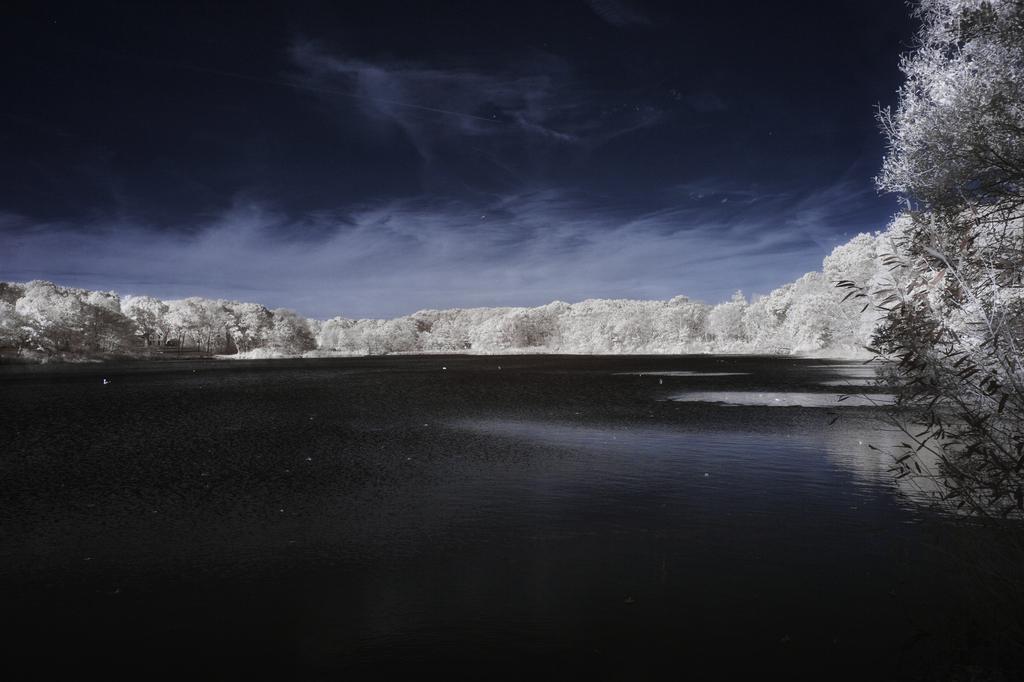Could you give a brief overview of what you see in this image? In this picture we can see water,trees and sky. 